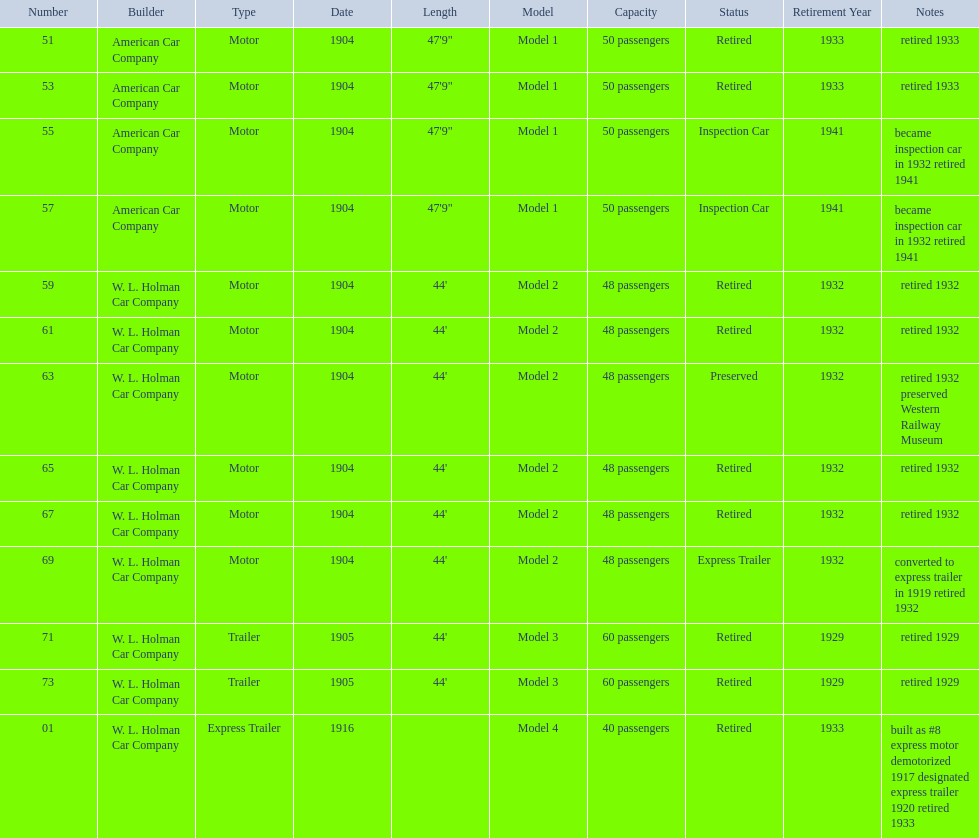Would you be able to parse every entry in this table? {'header': ['Number', 'Builder', 'Type', 'Date', 'Length', 'Model', 'Capacity', 'Status', 'Retirement Year', 'Notes'], 'rows': [['51', 'American Car Company', 'Motor', '1904', '47\'9"', 'Model 1', '50 passengers', 'Retired', '1933', 'retired 1933'], ['53', 'American Car Company', 'Motor', '1904', '47\'9"', 'Model 1', '50 passengers', 'Retired', '1933', 'retired 1933'], ['55', 'American Car Company', 'Motor', '1904', '47\'9"', 'Model 1', '50 passengers', 'Inspection Car', '1941', 'became inspection car in 1932 retired 1941'], ['57', 'American Car Company', 'Motor', '1904', '47\'9"', 'Model 1', '50 passengers', 'Inspection Car', '1941', 'became inspection car in 1932 retired 1941'], ['59', 'W. L. Holman Car Company', 'Motor', '1904', "44'", 'Model 2', '48 passengers', 'Retired', '1932', 'retired 1932'], ['61', 'W. L. Holman Car Company', 'Motor', '1904', "44'", 'Model 2', '48 passengers', 'Retired', '1932', 'retired 1932'], ['63', 'W. L. Holman Car Company', 'Motor', '1904', "44'", 'Model 2', '48 passengers', 'Preserved', '1932', 'retired 1932 preserved Western Railway Museum'], ['65', 'W. L. Holman Car Company', 'Motor', '1904', "44'", 'Model 2', '48 passengers', 'Retired', '1932', 'retired 1932'], ['67', 'W. L. Holman Car Company', 'Motor', '1904', "44'", 'Model 2', '48 passengers', 'Retired', '1932', 'retired 1932'], ['69', 'W. L. Holman Car Company', 'Motor', '1904', "44'", 'Model 2', '48 passengers', 'Express Trailer', '1932', 'converted to express trailer in 1919 retired 1932'], ['71', 'W. L. Holman Car Company', 'Trailer', '1905', "44'", 'Model 3', '60 passengers', 'Retired', '1929', 'retired 1929'], ['73', 'W. L. Holman Car Company', 'Trailer', '1905', "44'", 'Model 3', '60 passengers', 'Retired', '1929', 'retired 1929'], ['01', 'W. L. Holman Car Company', 'Express Trailer', '1916', '', 'Model 4', '40 passengers', 'Retired', '1933', 'built as #8 express motor demotorized 1917 designated express trailer 1920 retired 1933']]} What was the number of cars built by american car company? 4. 